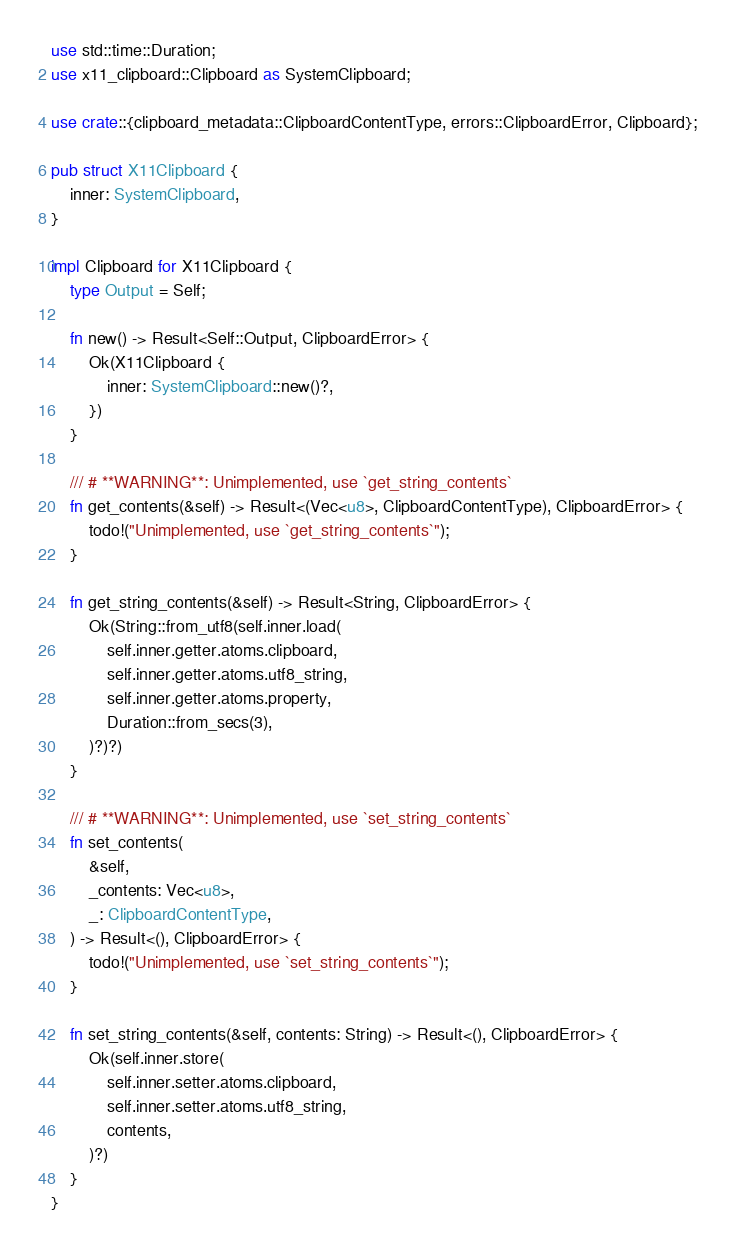Convert code to text. <code><loc_0><loc_0><loc_500><loc_500><_Rust_>use std::time::Duration;
use x11_clipboard::Clipboard as SystemClipboard;

use crate::{clipboard_metadata::ClipboardContentType, errors::ClipboardError, Clipboard};

pub struct X11Clipboard {
    inner: SystemClipboard,
}

impl Clipboard for X11Clipboard {
    type Output = Self;

    fn new() -> Result<Self::Output, ClipboardError> {
        Ok(X11Clipboard {
            inner: SystemClipboard::new()?,
        })
    }

    /// # **WARNING**: Unimplemented, use `get_string_contents`
    fn get_contents(&self) -> Result<(Vec<u8>, ClipboardContentType), ClipboardError> {
        todo!("Unimplemented, use `get_string_contents`");
    }

    fn get_string_contents(&self) -> Result<String, ClipboardError> {
        Ok(String::from_utf8(self.inner.load(
            self.inner.getter.atoms.clipboard,
            self.inner.getter.atoms.utf8_string,
            self.inner.getter.atoms.property,
            Duration::from_secs(3),
        )?)?)
    }

    /// # **WARNING**: Unimplemented, use `set_string_contents`
    fn set_contents(
        &self,
        _contents: Vec<u8>,
        _: ClipboardContentType,
    ) -> Result<(), ClipboardError> {
        todo!("Unimplemented, use `set_string_contents`");
    }

    fn set_string_contents(&self, contents: String) -> Result<(), ClipboardError> {
        Ok(self.inner.store(
            self.inner.setter.atoms.clipboard,
            self.inner.setter.atoms.utf8_string,
            contents,
        )?)
    }
}
</code> 